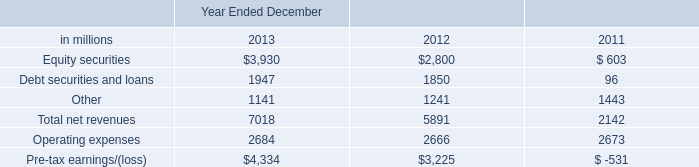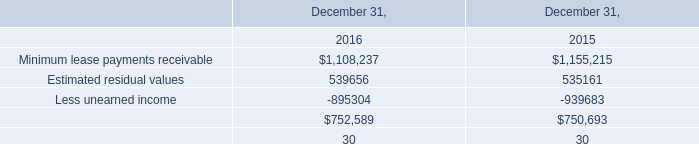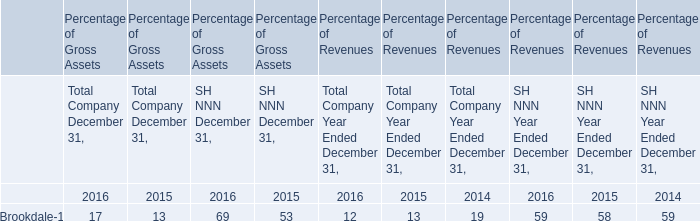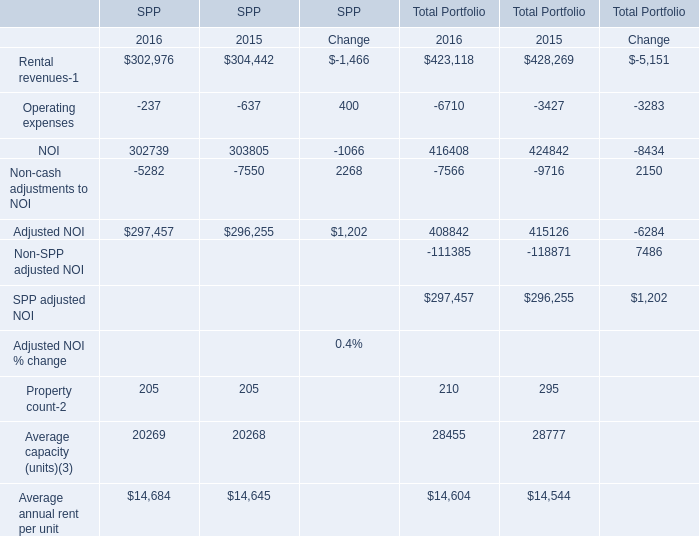What is the total amount of Other of Year Ended December 2011, and Adjusted NOI of SPP Change ? 
Computations: (1443.0 + 1202.0)
Answer: 2645.0. 